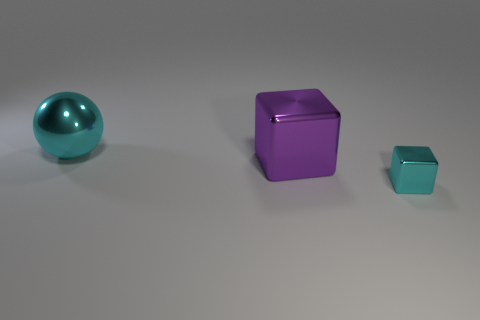How many blocks are cyan metal things or metallic objects?
Offer a very short reply. 2. How many tiny purple rubber blocks are there?
Your answer should be compact. 0. There is a cyan metallic object on the right side of the cyan metal thing that is to the left of the cyan shiny block; how big is it?
Ensure brevity in your answer.  Small. How many other things are there of the same size as the purple cube?
Ensure brevity in your answer.  1. There is a metallic sphere; what number of cyan things are on the right side of it?
Make the answer very short. 1. The purple object is what size?
Your answer should be compact. Large. Do the cyan object that is on the right side of the cyan sphere and the thing that is to the left of the large purple thing have the same material?
Keep it short and to the point. Yes. Are there any balls that have the same color as the small thing?
Give a very brief answer. Yes. What color is the shiny cube that is the same size as the cyan sphere?
Keep it short and to the point. Purple. There is a big object that is behind the big purple cube; does it have the same color as the large block?
Provide a short and direct response. No. 